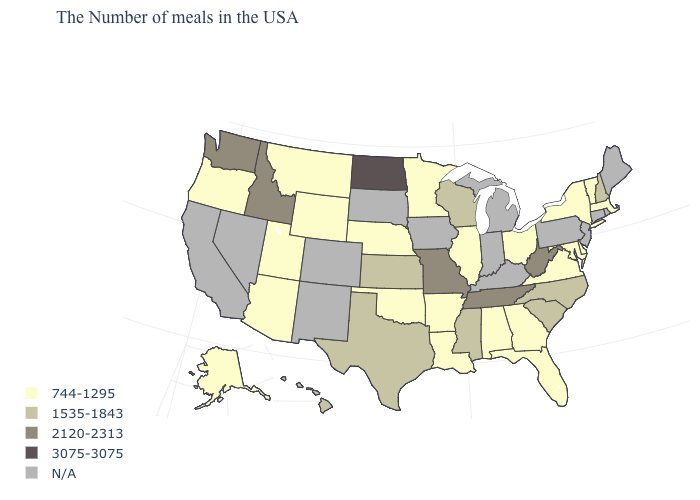Does North Dakota have the highest value in the MidWest?
Short answer required. Yes. What is the value of Iowa?
Give a very brief answer. N/A. Which states hav the highest value in the West?
Keep it brief. Idaho, Washington. Which states have the lowest value in the Northeast?
Answer briefly. Massachusetts, Vermont, New York. What is the value of Oregon?
Answer briefly. 744-1295. Name the states that have a value in the range 1535-1843?
Keep it brief. New Hampshire, North Carolina, South Carolina, Wisconsin, Mississippi, Kansas, Texas, Hawaii. Name the states that have a value in the range N/A?
Answer briefly. Maine, Rhode Island, Connecticut, New Jersey, Pennsylvania, Michigan, Kentucky, Indiana, Iowa, South Dakota, Colorado, New Mexico, Nevada, California. Is the legend a continuous bar?
Concise answer only. No. Which states have the highest value in the USA?
Answer briefly. North Dakota. Does West Virginia have the highest value in the South?
Answer briefly. Yes. Does Alaska have the highest value in the West?
Short answer required. No. Among the states that border Colorado , does Nebraska have the highest value?
Short answer required. No. Which states have the highest value in the USA?
Keep it brief. North Dakota. What is the value of Minnesota?
Give a very brief answer. 744-1295. Is the legend a continuous bar?
Give a very brief answer. No. 